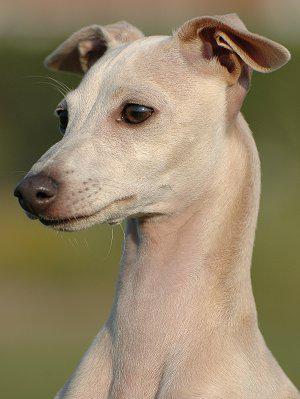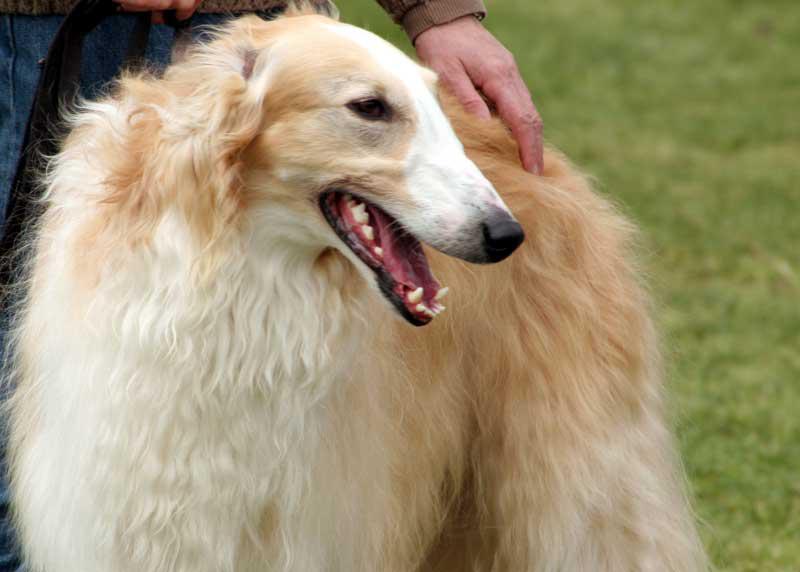The first image is the image on the left, the second image is the image on the right. For the images shown, is this caption "The dog in the image on the left is wearing a collar." true? Answer yes or no. No. 